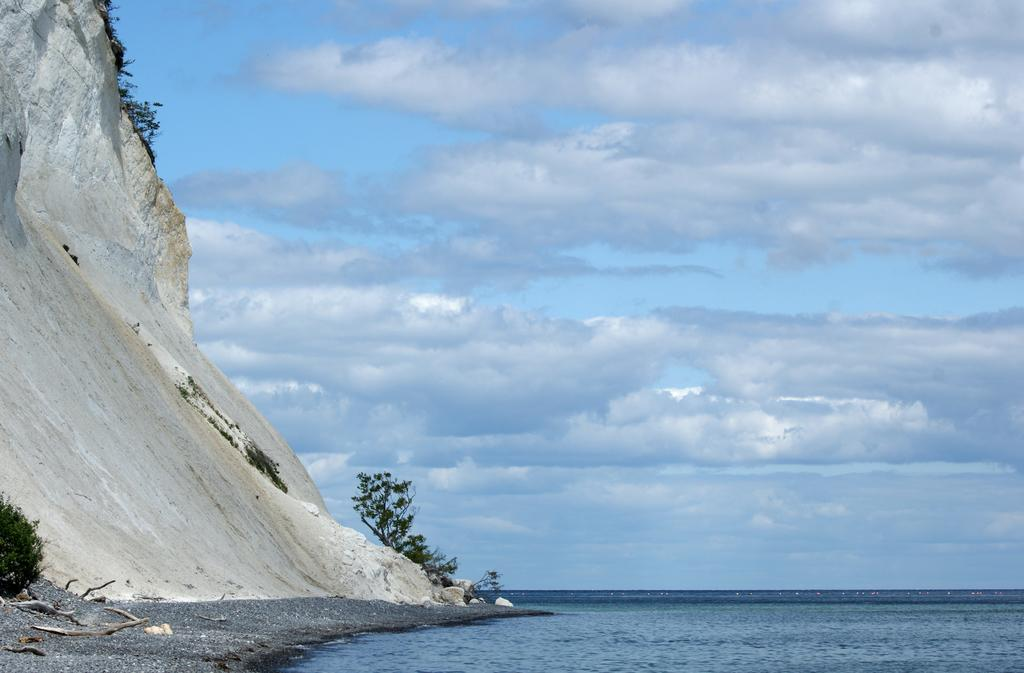What can be seen in the sky in the image? There are clouds in the sky in the image. What type of natural feature is visible in the image? There is a sea visible in the image. What is located on the left side of the image? There is a hill on the left side of the image, and there are also plants present. What else can be seen in the image that is related to vegetation? There are branches visible in the image. What story is being told by the street in the image? There is no street present in the image; it features clouds, a sea, a hill, plants, and branches. Who is the guide in the image? There is no guide present in the image. 